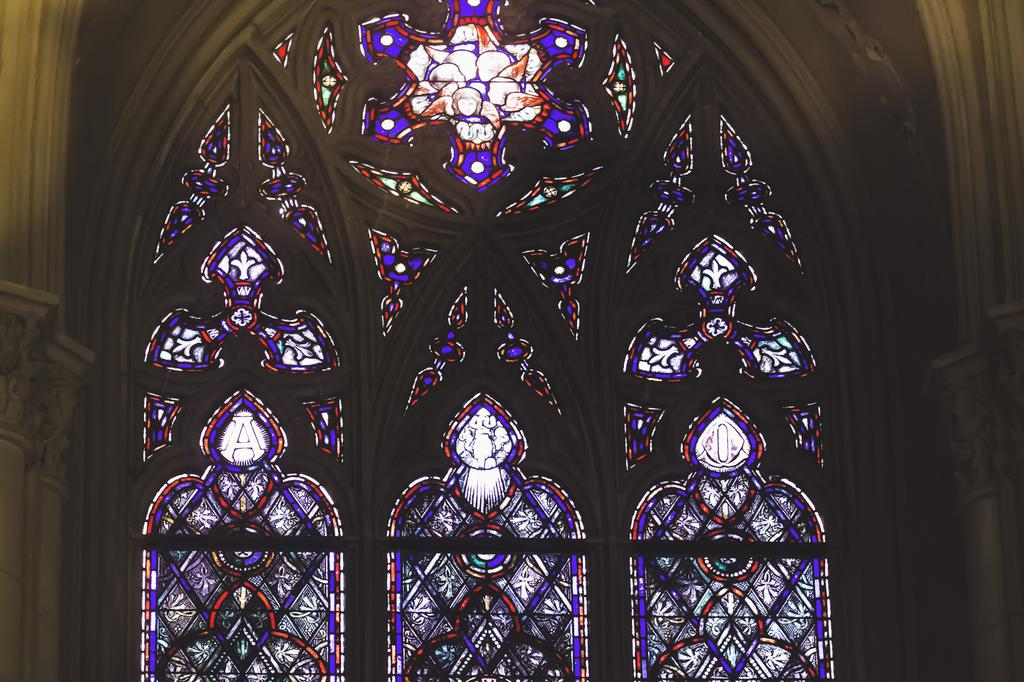What type of structure is present in the image? There is a stone arch in the image. What feature can be seen on the stone arch? The stone arch has a colorful window. How many cans are stacked on top of the stone arch in the image? There are no cans present in the image; it only features a stone arch with a colorful window. 